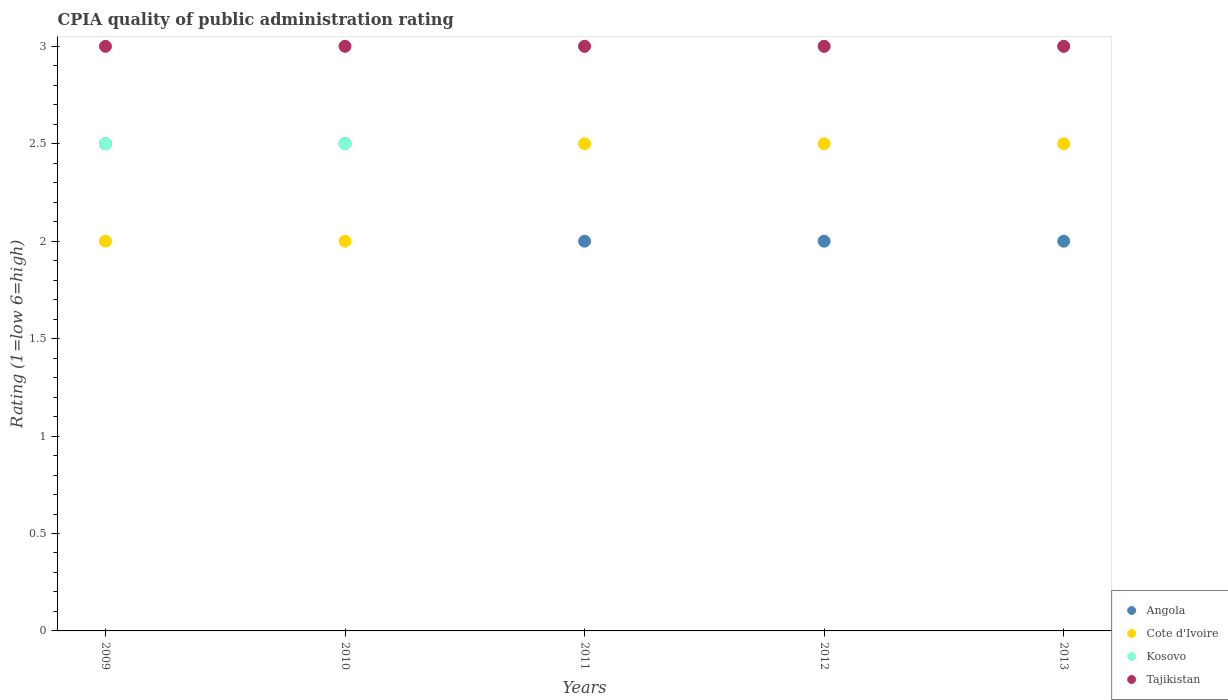How many different coloured dotlines are there?
Ensure brevity in your answer.  4. Across all years, what is the minimum CPIA rating in Tajikistan?
Ensure brevity in your answer.  3. In which year was the CPIA rating in Tajikistan maximum?
Provide a short and direct response. 2009. In which year was the CPIA rating in Cote d'Ivoire minimum?
Offer a terse response. 2009. What is the total CPIA rating in Cote d'Ivoire in the graph?
Keep it short and to the point. 11.5. In the year 2012, what is the difference between the CPIA rating in Angola and CPIA rating in Tajikistan?
Provide a short and direct response. -1. In how many years, is the CPIA rating in Cote d'Ivoire greater than 0.2?
Your answer should be compact. 5. What is the ratio of the CPIA rating in Tajikistan in 2010 to that in 2012?
Keep it short and to the point. 1. In how many years, is the CPIA rating in Angola greater than the average CPIA rating in Angola taken over all years?
Make the answer very short. 2. Is the sum of the CPIA rating in Kosovo in 2009 and 2013 greater than the maximum CPIA rating in Tajikistan across all years?
Your response must be concise. Yes. Is it the case that in every year, the sum of the CPIA rating in Tajikistan and CPIA rating in Angola  is greater than the sum of CPIA rating in Kosovo and CPIA rating in Cote d'Ivoire?
Your answer should be very brief. No. Is it the case that in every year, the sum of the CPIA rating in Cote d'Ivoire and CPIA rating in Angola  is greater than the CPIA rating in Kosovo?
Ensure brevity in your answer.  Yes. How many dotlines are there?
Give a very brief answer. 4. How many years are there in the graph?
Provide a succinct answer. 5. What is the difference between two consecutive major ticks on the Y-axis?
Your response must be concise. 0.5. Are the values on the major ticks of Y-axis written in scientific E-notation?
Give a very brief answer. No. Where does the legend appear in the graph?
Make the answer very short. Bottom right. How many legend labels are there?
Provide a succinct answer. 4. How are the legend labels stacked?
Ensure brevity in your answer.  Vertical. What is the title of the graph?
Your response must be concise. CPIA quality of public administration rating. What is the label or title of the X-axis?
Offer a very short reply. Years. What is the label or title of the Y-axis?
Make the answer very short. Rating (1=low 6=high). What is the Rating (1=low 6=high) in Angola in 2009?
Make the answer very short. 2.5. What is the Rating (1=low 6=high) in Angola in 2010?
Provide a succinct answer. 2.5. What is the Rating (1=low 6=high) of Kosovo in 2010?
Your response must be concise. 2.5. What is the Rating (1=low 6=high) in Angola in 2011?
Provide a succinct answer. 2. What is the Rating (1=low 6=high) of Kosovo in 2011?
Your answer should be very brief. 3. What is the Rating (1=low 6=high) in Cote d'Ivoire in 2012?
Ensure brevity in your answer.  2.5. What is the Rating (1=low 6=high) of Kosovo in 2012?
Provide a succinct answer. 3. What is the Rating (1=low 6=high) of Tajikistan in 2012?
Provide a short and direct response. 3. What is the Rating (1=low 6=high) of Angola in 2013?
Make the answer very short. 2. What is the Rating (1=low 6=high) of Cote d'Ivoire in 2013?
Make the answer very short. 2.5. Across all years, what is the maximum Rating (1=low 6=high) in Cote d'Ivoire?
Make the answer very short. 2.5. Across all years, what is the maximum Rating (1=low 6=high) in Tajikistan?
Provide a short and direct response. 3. What is the total Rating (1=low 6=high) of Angola in the graph?
Provide a short and direct response. 11. What is the total Rating (1=low 6=high) of Cote d'Ivoire in the graph?
Offer a terse response. 11.5. What is the difference between the Rating (1=low 6=high) of Cote d'Ivoire in 2009 and that in 2011?
Provide a short and direct response. -0.5. What is the difference between the Rating (1=low 6=high) in Kosovo in 2009 and that in 2011?
Provide a succinct answer. -0.5. What is the difference between the Rating (1=low 6=high) of Tajikistan in 2009 and that in 2011?
Make the answer very short. 0. What is the difference between the Rating (1=low 6=high) in Kosovo in 2009 and that in 2012?
Provide a succinct answer. -0.5. What is the difference between the Rating (1=low 6=high) of Kosovo in 2009 and that in 2013?
Keep it short and to the point. -0.5. What is the difference between the Rating (1=low 6=high) in Tajikistan in 2009 and that in 2013?
Provide a short and direct response. 0. What is the difference between the Rating (1=low 6=high) in Cote d'Ivoire in 2010 and that in 2011?
Your answer should be compact. -0.5. What is the difference between the Rating (1=low 6=high) in Kosovo in 2010 and that in 2011?
Provide a short and direct response. -0.5. What is the difference between the Rating (1=low 6=high) in Cote d'Ivoire in 2010 and that in 2012?
Offer a terse response. -0.5. What is the difference between the Rating (1=low 6=high) of Angola in 2010 and that in 2013?
Ensure brevity in your answer.  0.5. What is the difference between the Rating (1=low 6=high) in Tajikistan in 2010 and that in 2013?
Give a very brief answer. 0. What is the difference between the Rating (1=low 6=high) in Angola in 2011 and that in 2012?
Your answer should be compact. 0. What is the difference between the Rating (1=low 6=high) of Cote d'Ivoire in 2011 and that in 2012?
Provide a succinct answer. 0. What is the difference between the Rating (1=low 6=high) of Tajikistan in 2011 and that in 2012?
Keep it short and to the point. 0. What is the difference between the Rating (1=low 6=high) of Angola in 2011 and that in 2013?
Your response must be concise. 0. What is the difference between the Rating (1=low 6=high) of Tajikistan in 2011 and that in 2013?
Your answer should be very brief. 0. What is the difference between the Rating (1=low 6=high) in Angola in 2012 and that in 2013?
Your response must be concise. 0. What is the difference between the Rating (1=low 6=high) of Cote d'Ivoire in 2012 and that in 2013?
Provide a succinct answer. 0. What is the difference between the Rating (1=low 6=high) of Tajikistan in 2012 and that in 2013?
Offer a very short reply. 0. What is the difference between the Rating (1=low 6=high) in Angola in 2009 and the Rating (1=low 6=high) in Tajikistan in 2010?
Give a very brief answer. -0.5. What is the difference between the Rating (1=low 6=high) of Cote d'Ivoire in 2009 and the Rating (1=low 6=high) of Kosovo in 2010?
Give a very brief answer. -0.5. What is the difference between the Rating (1=low 6=high) in Cote d'Ivoire in 2009 and the Rating (1=low 6=high) in Tajikistan in 2010?
Give a very brief answer. -1. What is the difference between the Rating (1=low 6=high) in Cote d'Ivoire in 2009 and the Rating (1=low 6=high) in Tajikistan in 2011?
Provide a short and direct response. -1. What is the difference between the Rating (1=low 6=high) of Angola in 2009 and the Rating (1=low 6=high) of Cote d'Ivoire in 2012?
Your answer should be very brief. 0. What is the difference between the Rating (1=low 6=high) of Angola in 2009 and the Rating (1=low 6=high) of Kosovo in 2012?
Your answer should be very brief. -0.5. What is the difference between the Rating (1=low 6=high) in Angola in 2009 and the Rating (1=low 6=high) in Tajikistan in 2012?
Offer a very short reply. -0.5. What is the difference between the Rating (1=low 6=high) in Angola in 2009 and the Rating (1=low 6=high) in Cote d'Ivoire in 2013?
Keep it short and to the point. 0. What is the difference between the Rating (1=low 6=high) in Angola in 2009 and the Rating (1=low 6=high) in Kosovo in 2013?
Offer a terse response. -0.5. What is the difference between the Rating (1=low 6=high) of Cote d'Ivoire in 2009 and the Rating (1=low 6=high) of Kosovo in 2013?
Your answer should be compact. -1. What is the difference between the Rating (1=low 6=high) of Kosovo in 2009 and the Rating (1=low 6=high) of Tajikistan in 2013?
Your response must be concise. -0.5. What is the difference between the Rating (1=low 6=high) in Angola in 2010 and the Rating (1=low 6=high) in Cote d'Ivoire in 2011?
Ensure brevity in your answer.  0. What is the difference between the Rating (1=low 6=high) in Cote d'Ivoire in 2010 and the Rating (1=low 6=high) in Kosovo in 2011?
Your answer should be compact. -1. What is the difference between the Rating (1=low 6=high) in Angola in 2010 and the Rating (1=low 6=high) in Cote d'Ivoire in 2012?
Offer a very short reply. 0. What is the difference between the Rating (1=low 6=high) in Cote d'Ivoire in 2010 and the Rating (1=low 6=high) in Kosovo in 2012?
Provide a short and direct response. -1. What is the difference between the Rating (1=low 6=high) in Cote d'Ivoire in 2010 and the Rating (1=low 6=high) in Tajikistan in 2012?
Offer a terse response. -1. What is the difference between the Rating (1=low 6=high) in Kosovo in 2010 and the Rating (1=low 6=high) in Tajikistan in 2012?
Make the answer very short. -0.5. What is the difference between the Rating (1=low 6=high) of Angola in 2010 and the Rating (1=low 6=high) of Kosovo in 2013?
Offer a very short reply. -0.5. What is the difference between the Rating (1=low 6=high) in Angola in 2010 and the Rating (1=low 6=high) in Tajikistan in 2013?
Ensure brevity in your answer.  -0.5. What is the difference between the Rating (1=low 6=high) of Cote d'Ivoire in 2011 and the Rating (1=low 6=high) of Kosovo in 2012?
Offer a very short reply. -0.5. What is the difference between the Rating (1=low 6=high) of Kosovo in 2011 and the Rating (1=low 6=high) of Tajikistan in 2012?
Offer a terse response. 0. What is the difference between the Rating (1=low 6=high) of Angola in 2011 and the Rating (1=low 6=high) of Cote d'Ivoire in 2013?
Your response must be concise. -0.5. What is the difference between the Rating (1=low 6=high) of Angola in 2011 and the Rating (1=low 6=high) of Kosovo in 2013?
Ensure brevity in your answer.  -1. What is the difference between the Rating (1=low 6=high) in Angola in 2011 and the Rating (1=low 6=high) in Tajikistan in 2013?
Give a very brief answer. -1. What is the difference between the Rating (1=low 6=high) in Kosovo in 2011 and the Rating (1=low 6=high) in Tajikistan in 2013?
Make the answer very short. 0. What is the average Rating (1=low 6=high) in Cote d'Ivoire per year?
Provide a succinct answer. 2.3. What is the average Rating (1=low 6=high) in Kosovo per year?
Give a very brief answer. 2.8. What is the average Rating (1=low 6=high) of Tajikistan per year?
Make the answer very short. 3. In the year 2009, what is the difference between the Rating (1=low 6=high) of Angola and Rating (1=low 6=high) of Cote d'Ivoire?
Your answer should be compact. 0.5. In the year 2009, what is the difference between the Rating (1=low 6=high) in Angola and Rating (1=low 6=high) in Kosovo?
Provide a succinct answer. 0. In the year 2009, what is the difference between the Rating (1=low 6=high) of Cote d'Ivoire and Rating (1=low 6=high) of Tajikistan?
Make the answer very short. -1. In the year 2009, what is the difference between the Rating (1=low 6=high) of Kosovo and Rating (1=low 6=high) of Tajikistan?
Offer a very short reply. -0.5. In the year 2010, what is the difference between the Rating (1=low 6=high) of Angola and Rating (1=low 6=high) of Kosovo?
Ensure brevity in your answer.  0. In the year 2010, what is the difference between the Rating (1=low 6=high) of Angola and Rating (1=low 6=high) of Tajikistan?
Make the answer very short. -0.5. In the year 2010, what is the difference between the Rating (1=low 6=high) of Cote d'Ivoire and Rating (1=low 6=high) of Tajikistan?
Provide a short and direct response. -1. In the year 2010, what is the difference between the Rating (1=low 6=high) of Kosovo and Rating (1=low 6=high) of Tajikistan?
Offer a very short reply. -0.5. In the year 2011, what is the difference between the Rating (1=low 6=high) of Angola and Rating (1=low 6=high) of Cote d'Ivoire?
Provide a short and direct response. -0.5. In the year 2011, what is the difference between the Rating (1=low 6=high) in Kosovo and Rating (1=low 6=high) in Tajikistan?
Offer a terse response. 0. In the year 2012, what is the difference between the Rating (1=low 6=high) in Angola and Rating (1=low 6=high) in Cote d'Ivoire?
Make the answer very short. -0.5. In the year 2012, what is the difference between the Rating (1=low 6=high) in Angola and Rating (1=low 6=high) in Kosovo?
Your response must be concise. -1. In the year 2012, what is the difference between the Rating (1=low 6=high) in Cote d'Ivoire and Rating (1=low 6=high) in Kosovo?
Offer a very short reply. -0.5. In the year 2012, what is the difference between the Rating (1=low 6=high) in Kosovo and Rating (1=low 6=high) in Tajikistan?
Make the answer very short. 0. In the year 2013, what is the difference between the Rating (1=low 6=high) in Angola and Rating (1=low 6=high) in Tajikistan?
Offer a very short reply. -1. In the year 2013, what is the difference between the Rating (1=low 6=high) in Cote d'Ivoire and Rating (1=low 6=high) in Kosovo?
Your response must be concise. -0.5. In the year 2013, what is the difference between the Rating (1=low 6=high) in Kosovo and Rating (1=low 6=high) in Tajikistan?
Keep it short and to the point. 0. What is the ratio of the Rating (1=low 6=high) in Angola in 2009 to that in 2010?
Offer a very short reply. 1. What is the ratio of the Rating (1=low 6=high) in Kosovo in 2009 to that in 2010?
Ensure brevity in your answer.  1. What is the ratio of the Rating (1=low 6=high) in Angola in 2009 to that in 2011?
Your answer should be very brief. 1.25. What is the ratio of the Rating (1=low 6=high) of Kosovo in 2009 to that in 2011?
Provide a succinct answer. 0.83. What is the ratio of the Rating (1=low 6=high) of Tajikistan in 2009 to that in 2011?
Provide a succinct answer. 1. What is the ratio of the Rating (1=low 6=high) in Cote d'Ivoire in 2009 to that in 2012?
Your answer should be compact. 0.8. What is the ratio of the Rating (1=low 6=high) in Tajikistan in 2009 to that in 2012?
Provide a succinct answer. 1. What is the ratio of the Rating (1=low 6=high) in Tajikistan in 2009 to that in 2013?
Your response must be concise. 1. What is the ratio of the Rating (1=low 6=high) in Angola in 2010 to that in 2011?
Make the answer very short. 1.25. What is the ratio of the Rating (1=low 6=high) in Cote d'Ivoire in 2010 to that in 2011?
Make the answer very short. 0.8. What is the ratio of the Rating (1=low 6=high) in Kosovo in 2010 to that in 2011?
Make the answer very short. 0.83. What is the ratio of the Rating (1=low 6=high) of Tajikistan in 2010 to that in 2011?
Provide a succinct answer. 1. What is the ratio of the Rating (1=low 6=high) of Cote d'Ivoire in 2010 to that in 2013?
Offer a very short reply. 0.8. What is the ratio of the Rating (1=low 6=high) of Kosovo in 2010 to that in 2013?
Make the answer very short. 0.83. What is the ratio of the Rating (1=low 6=high) in Angola in 2011 to that in 2012?
Give a very brief answer. 1. What is the ratio of the Rating (1=low 6=high) in Kosovo in 2011 to that in 2012?
Give a very brief answer. 1. What is the ratio of the Rating (1=low 6=high) of Tajikistan in 2011 to that in 2012?
Your answer should be very brief. 1. What is the ratio of the Rating (1=low 6=high) in Cote d'Ivoire in 2011 to that in 2013?
Make the answer very short. 1. What is the ratio of the Rating (1=low 6=high) of Kosovo in 2011 to that in 2013?
Provide a short and direct response. 1. What is the ratio of the Rating (1=low 6=high) of Tajikistan in 2011 to that in 2013?
Ensure brevity in your answer.  1. What is the ratio of the Rating (1=low 6=high) in Kosovo in 2012 to that in 2013?
Keep it short and to the point. 1. What is the difference between the highest and the second highest Rating (1=low 6=high) in Angola?
Give a very brief answer. 0. What is the difference between the highest and the second highest Rating (1=low 6=high) of Cote d'Ivoire?
Provide a succinct answer. 0. What is the difference between the highest and the lowest Rating (1=low 6=high) of Tajikistan?
Your response must be concise. 0. 